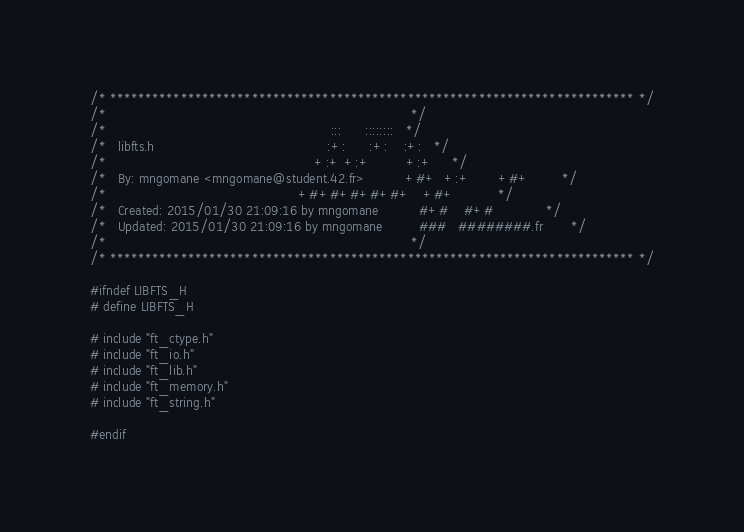Convert code to text. <code><loc_0><loc_0><loc_500><loc_500><_C_>/* ************************************************************************** */
/*                                                                            */
/*                                                        :::      ::::::::   */
/*   libfts.h                                           :+:      :+:    :+:   */
/*                                                    +:+ +:+         +:+     */
/*   By: mngomane <mngomane@student.42.fr>          +#+  +:+       +#+        */
/*                                                +#+#+#+#+#+   +#+           */
/*   Created: 2015/01/30 21:09:16 by mngomane          #+#    #+#             */
/*   Updated: 2015/01/30 21:09:16 by mngomane         ###   ########.fr       */
/*                                                                            */
/* ************************************************************************** */

#ifndef LIBFTS_H
# define LIBFTS_H

# include "ft_ctype.h"
# include "ft_io.h"
# include "ft_lib.h"
# include "ft_memory.h"
# include "ft_string.h"

#endif
</code> 